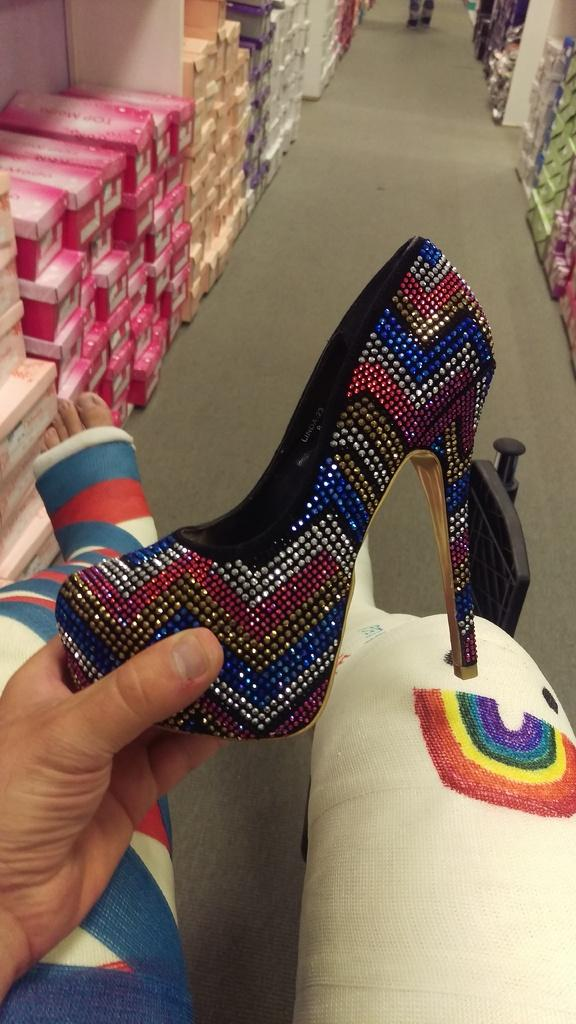Who or what is present in the image? There is a person in the image. What is the person holding in the image? The person is holding a sandal. What else can be seen in the image besides the person and the sandal? There are boxes visible in the image. What type of key is being used to unlock the sky in the image? There is no key or sky present in the image; it only features a person holding a sandal and some boxes. 